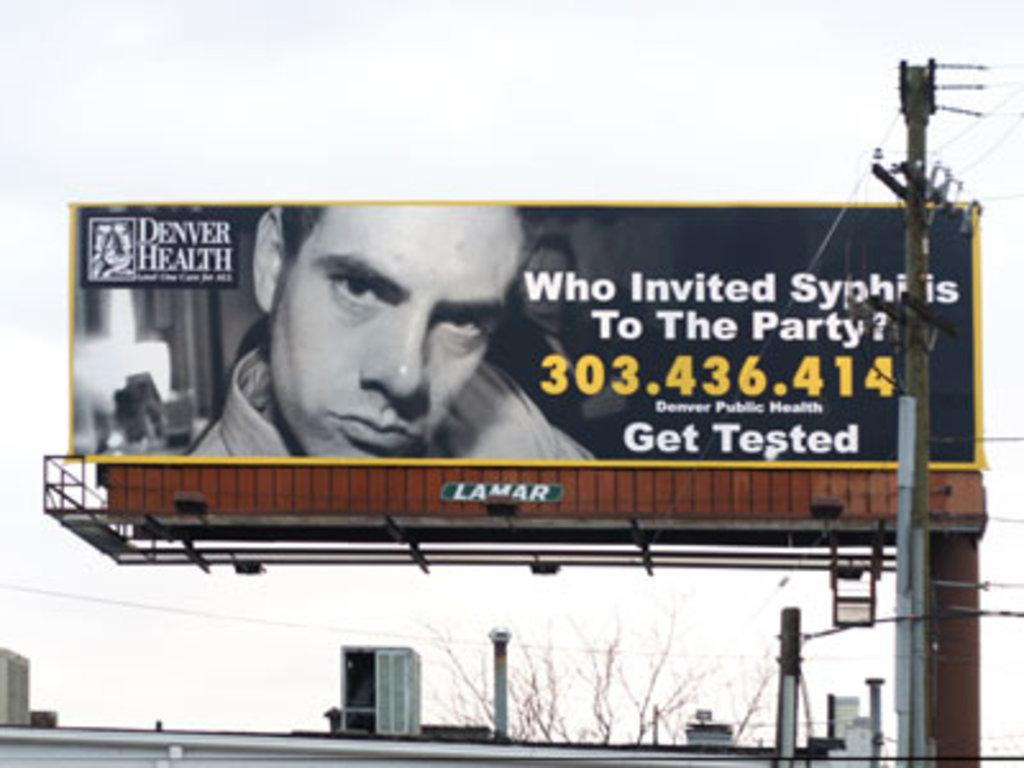<image>
Describe the image concisely. A billboard that reads Who Invited Syphilis To The Party. 